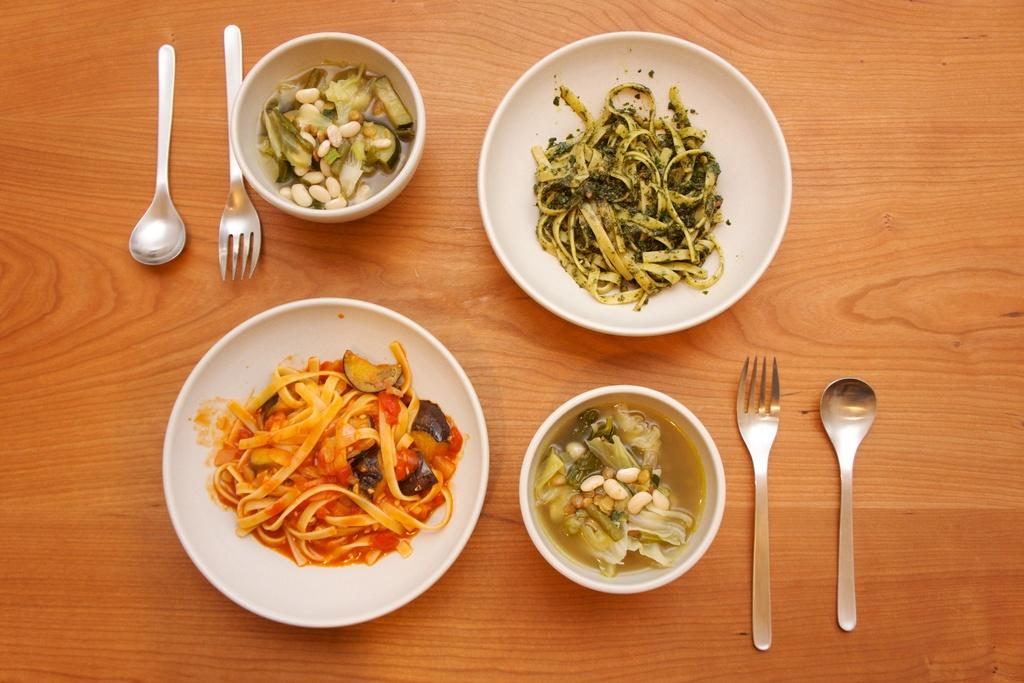What type of food items can be seen on plates in the image? There are food items on plates in the image. What type of food items can be seen in bowls in the image? There are food items in bowls in the image. What utensils are present in the image? There are forks and spoons in the image. Where are the food items, forks, and spoons located? The food items, forks, and spoons are on a table. What type of boats can be seen in the image? There are no boats present in the image; it features food items on plates and in bowls, along with forks and spoons on a table. 